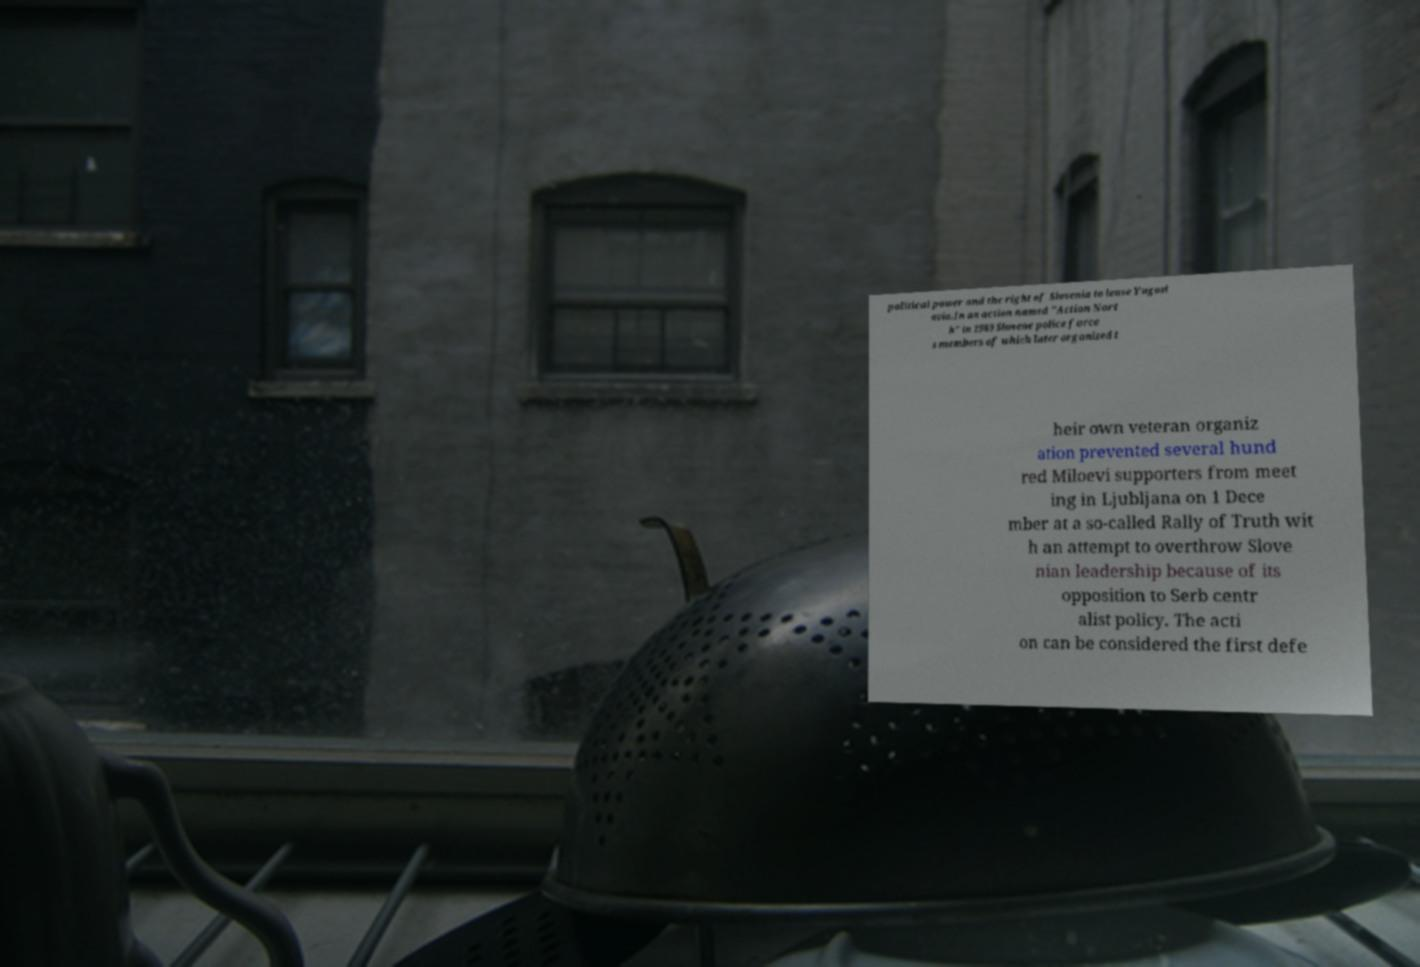Please identify and transcribe the text found in this image. political power and the right of Slovenia to leave Yugosl avia.In an action named "Action Nort h" in 1989 Slovene police force s members of which later organized t heir own veteran organiz ation prevented several hund red Miloevi supporters from meet ing in Ljubljana on 1 Dece mber at a so-called Rally of Truth wit h an attempt to overthrow Slove nian leadership because of its opposition to Serb centr alist policy. The acti on can be considered the first defe 